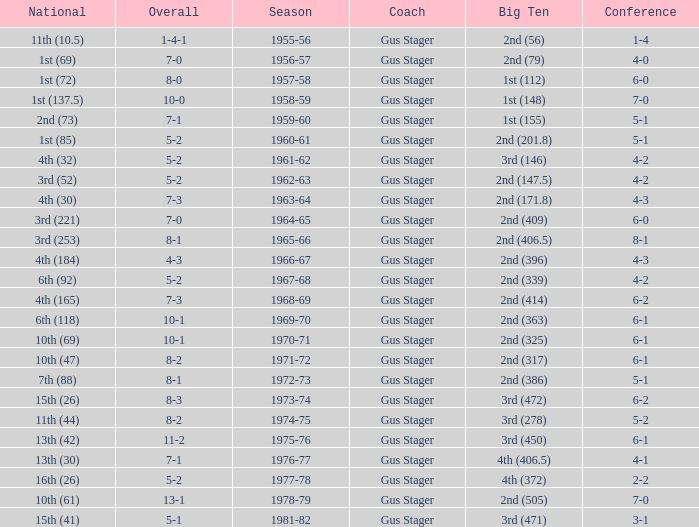What is the Coach with a Big Ten that is 1st (148)? Gus Stager. 